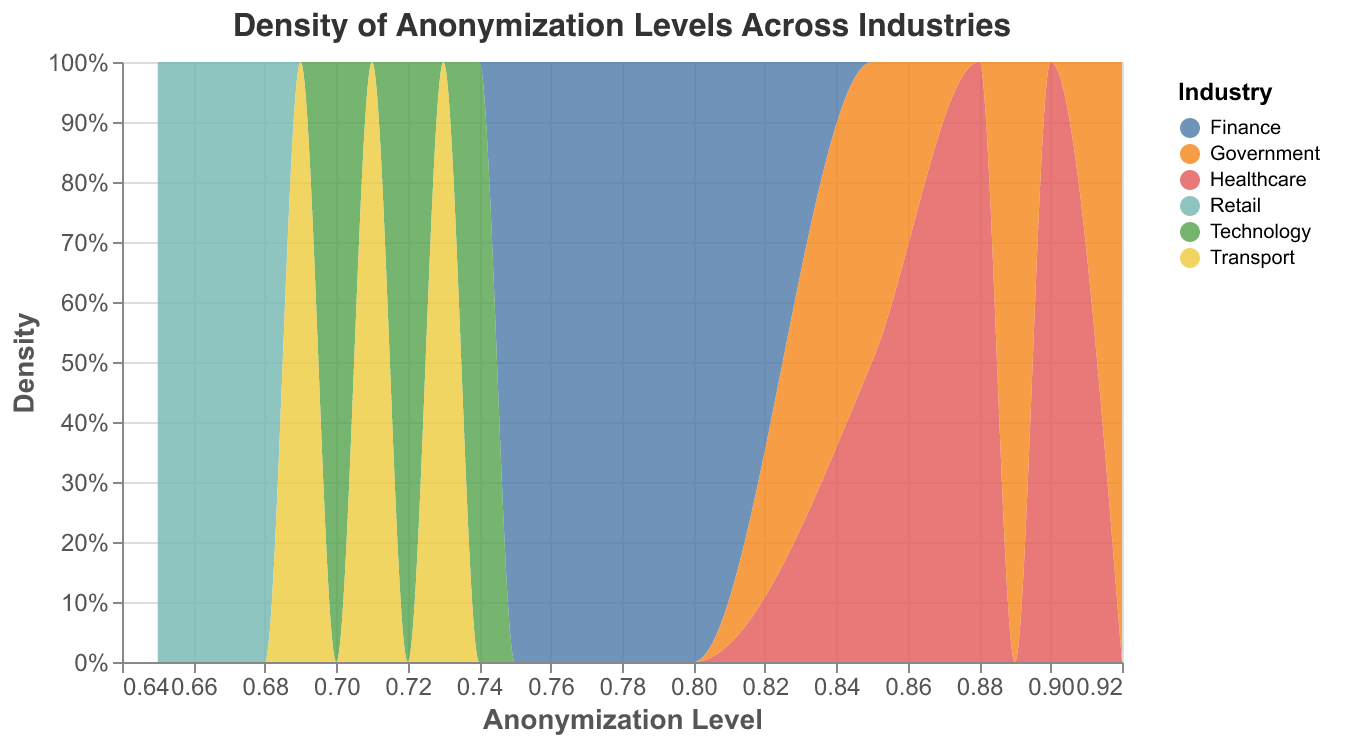What is the title of the plot? The title of the plot is displayed at the top and reads "Density of Anonymization Levels Across Industries".
Answer: Density of Anonymization Levels Across Industries What does the y-axis represent? The y-axis represents the "Density" and shows the normalized count of data points within each industry.
Answer: Density Which industry has the highest peak density in the plot? To find the highest peak density, observe where the y-axis values are at their maximum height. The "Government" industry shows a higher peak compared to other industries.
Answer: Government What range of anonymization levels is mostly covered by the Healthcare industry? By observing the width of the Healthcare industry's density curve along the x-axis, it mainly spans from approximately 0.85 to 0.90.
Answer: 0.85 to 0.90 Are the anonymization levels of the Finance industry generally higher or lower than those of the Government industry? Compare the positions of the density curves along the x-axis. The Finance industry curves appear to be generally to the left of the Government industry curves, indicating lower levels.
Answer: Lower How many industries are represented in the plot? The different colors in the plot represent different industries. By referring to the color legend, there are six industries (Healthcare, Finance, Government, Technology, Retail, Transport).
Answer: Six Which industry has the broadest range of anonymization levels? Notice the spread of density curves along the x-axis. The Retail industry has a range spanning from about 0.65 to 0.68, which is the broadest compared to other industries.
Answer: Retail What is the lowest anonymization level within the Technology industry? The Technology industry density curve starts around the lowest point on the x-axis at 0.70.
Answer: 0.70 Does the Finance industry have density peaks higher than the Technology industry within the same anonymization level range? By comparing the heights of the density curves within overlapping x-axis ranges (0.70 to 0.80), the Finance industry density peak appears taller.
Answer: Yes What anonymization level does the Government industry show its peak density? The highest point of the Government industry's density curve corresponds to an anonymization level around 0.92.
Answer: 0.92 